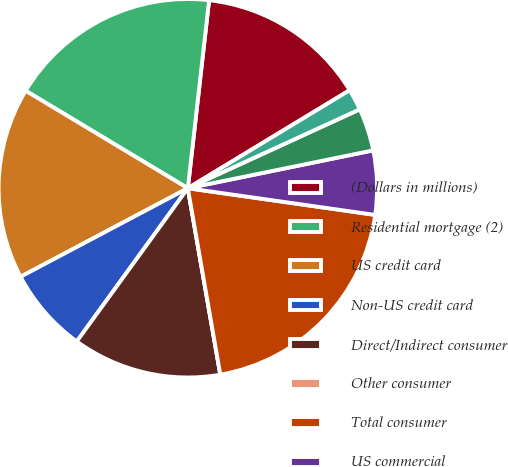Convert chart. <chart><loc_0><loc_0><loc_500><loc_500><pie_chart><fcel>(Dollars in millions)<fcel>Residential mortgage (2)<fcel>US credit card<fcel>Non-US credit card<fcel>Direct/Indirect consumer<fcel>Other consumer<fcel>Total consumer<fcel>US commercial<fcel>Commercial real estate<fcel>Commercial lease financing<nl><fcel>14.54%<fcel>18.18%<fcel>16.36%<fcel>7.27%<fcel>12.73%<fcel>0.0%<fcel>20.0%<fcel>5.46%<fcel>3.64%<fcel>1.82%<nl></chart> 